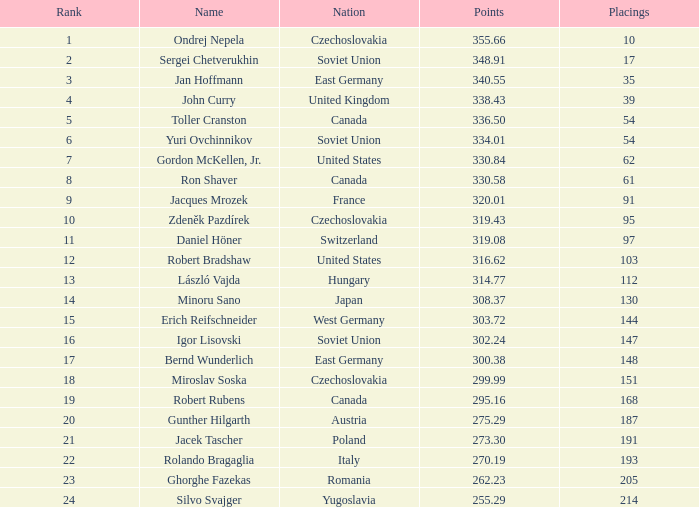Which rank holds a name of john curry and points surpassing 33 None. 